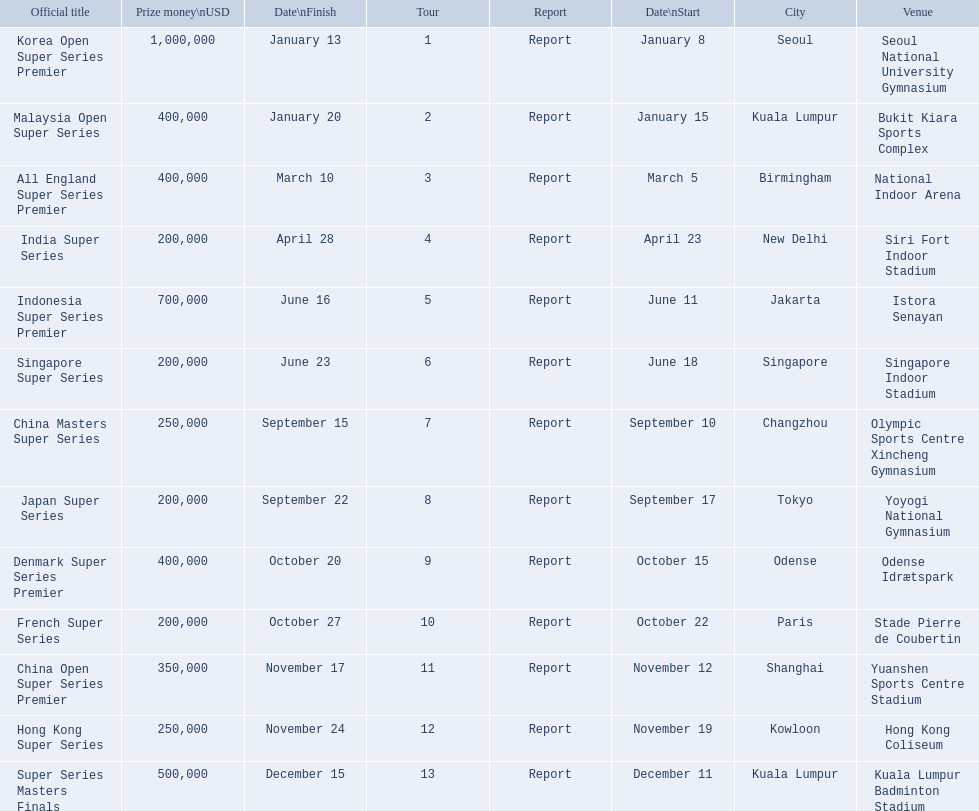What are all the titles? Korea Open Super Series Premier, Malaysia Open Super Series, All England Super Series Premier, India Super Series, Indonesia Super Series Premier, Singapore Super Series, China Masters Super Series, Japan Super Series, Denmark Super Series Premier, French Super Series, China Open Super Series Premier, Hong Kong Super Series, Super Series Masters Finals. When did they take place? January 8, January 15, March 5, April 23, June 11, June 18, September 10, September 17, October 15, October 22, November 12, November 19, December 11. Which title took place in december? Super Series Masters Finals. 